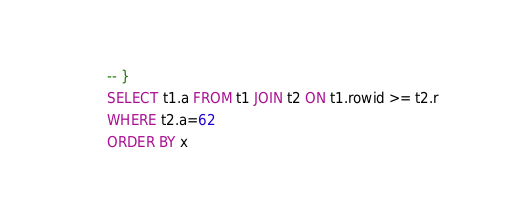<code> <loc_0><loc_0><loc_500><loc_500><_SQL_>-- }
SELECT t1.a FROM t1 JOIN t2 ON t1.rowid >= t2.r
WHERE t2.a=62
ORDER BY x</code> 